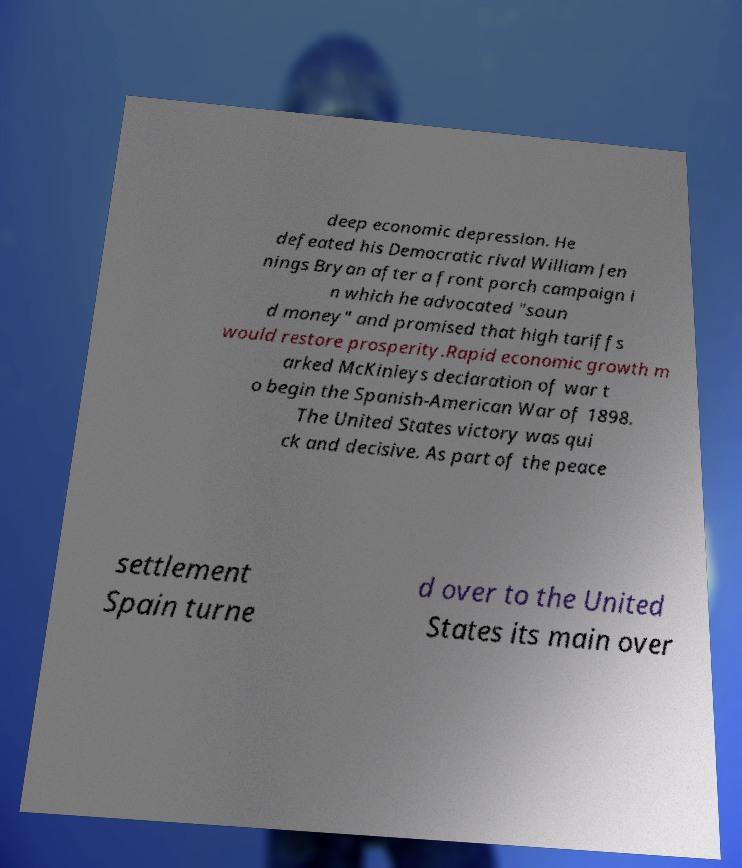For documentation purposes, I need the text within this image transcribed. Could you provide that? deep economic depression. He defeated his Democratic rival William Jen nings Bryan after a front porch campaign i n which he advocated "soun d money" and promised that high tariffs would restore prosperity.Rapid economic growth m arked McKinleys declaration of war t o begin the Spanish-American War of 1898. The United States victory was qui ck and decisive. As part of the peace settlement Spain turne d over to the United States its main over 